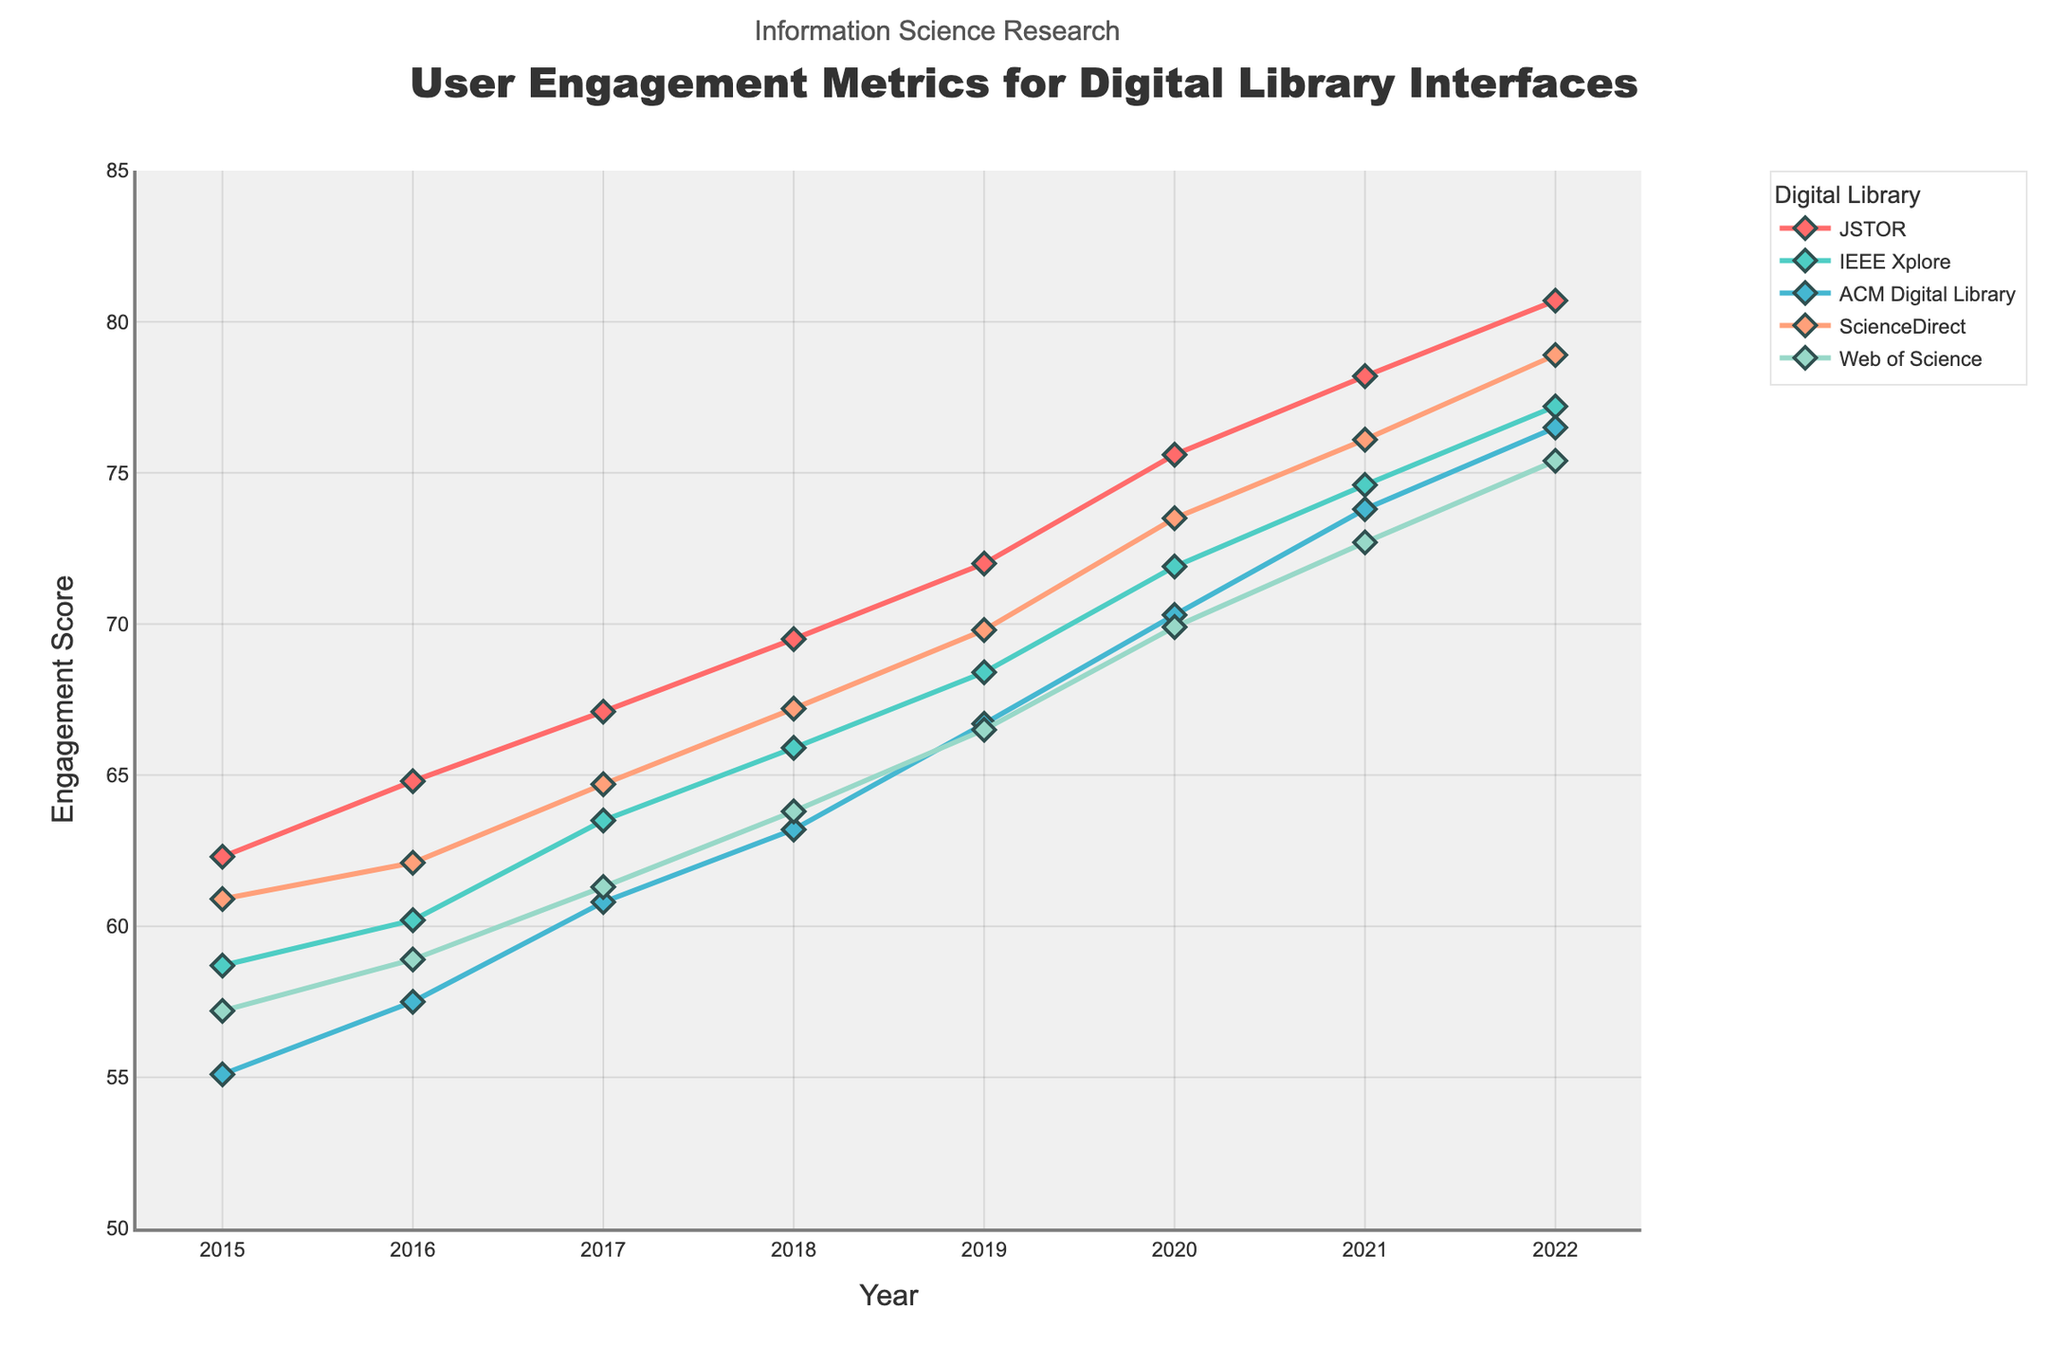Which digital library had the highest user engagement score in 2022? Look for the highest point in 2022 on the y-axis among all the lines. JSTOR has the highest user engagement score at around 80.7 in 2022.
Answer: JSTOR Which two digital libraries had the smallest difference in user engagement scores in 2017? Find the engagement scores for all digital libraries in 2017 and calculate the differences. IEEE Xplore and ScienceDirect had scores of 63.5 and 64.7 respectively, so their difference is 1.2, which is the smallest.
Answer: IEEE Xplore and ScienceDirect What was the average user engagement score for Web of Science from 2015 to 2022? Add the user engagement scores of Web of Science for each year from 2015 to 2022, then divide by the number of years. (57.2 + 58.9 + 61.3 + 63.8 + 66.5 + 69.9 + 72.7 + 75.4) / 8 = 65.95.
Answer: 65.95 Which digital library showed the greatest increase in user engagement score from 2015 to 2022? Calculate the difference between the 2015 and 2022 scores for all digital libraries. JSTOR had the greatest increase, going from 62.3 to 80.7, which is an increase of 18.4.
Answer: JSTOR Between 2019 and 2020, which digital library had the largest increase in user engagement score? Compare the engagement scores from 2019 to 2020 for each digital library. JSTOR’s score increased from 72.0 to 75.6, which is an increase of 3.6, the largest among them.
Answer: JSTOR In which year did ACM Digital Library's user engagement score surpass 70 for the first time? Look for the point where the ACM Digital Library line crosses 70 on the y-axis. This occurs in 2020.
Answer: 2020 How many digital libraries had a user engagement score greater than 75 in 2022? Check the engagement scores in 2022, counting how many exceed 75. JSTOR, ACM Digital Library, ScienceDirect, and Web of Science all have scores higher than 75.
Answer: Four If you average the user engagement scores for JSTOR and IEEE Xplore in 2020, what do you get? Add the 2020 engagement scores for JSTOR and IEEE Xplore, then divide by 2. (75.6 + 71.9) / 2 = 73.75.
Answer: 73.75 What is the trend in user engagement scores for ScienceDirect from 2015 to 2022? Observe the line for ScienceDirect from left to right (2015 to 2022). The trend shows a consistent increase in user engagement scores.
Answer: Increasing 